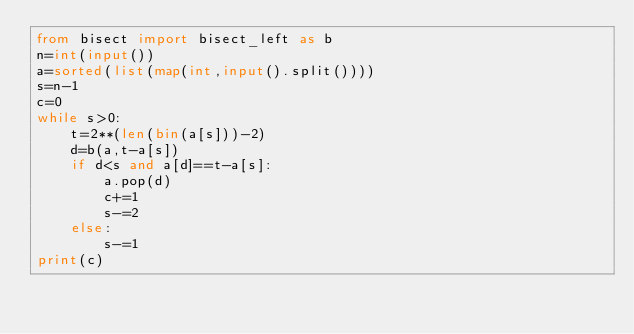<code> <loc_0><loc_0><loc_500><loc_500><_Python_>from bisect import bisect_left as b
n=int(input())
a=sorted(list(map(int,input().split())))
s=n-1
c=0
while s>0:
    t=2**(len(bin(a[s]))-2)
    d=b(a,t-a[s])
    if d<s and a[d]==t-a[s]:
        a.pop(d)
        c+=1
        s-=2
    else:
        s-=1
print(c)</code> 